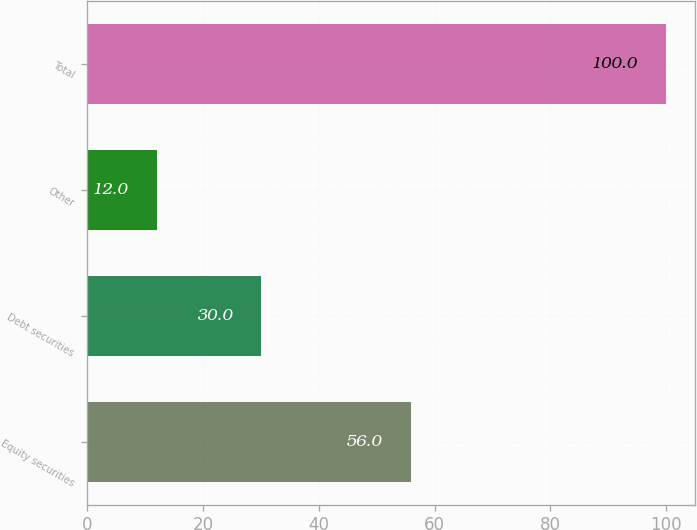Convert chart. <chart><loc_0><loc_0><loc_500><loc_500><bar_chart><fcel>Equity securities<fcel>Debt securities<fcel>Other<fcel>Total<nl><fcel>56<fcel>30<fcel>12<fcel>100<nl></chart> 